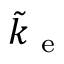<formula> <loc_0><loc_0><loc_500><loc_500>\tilde { k } _ { e }</formula> 